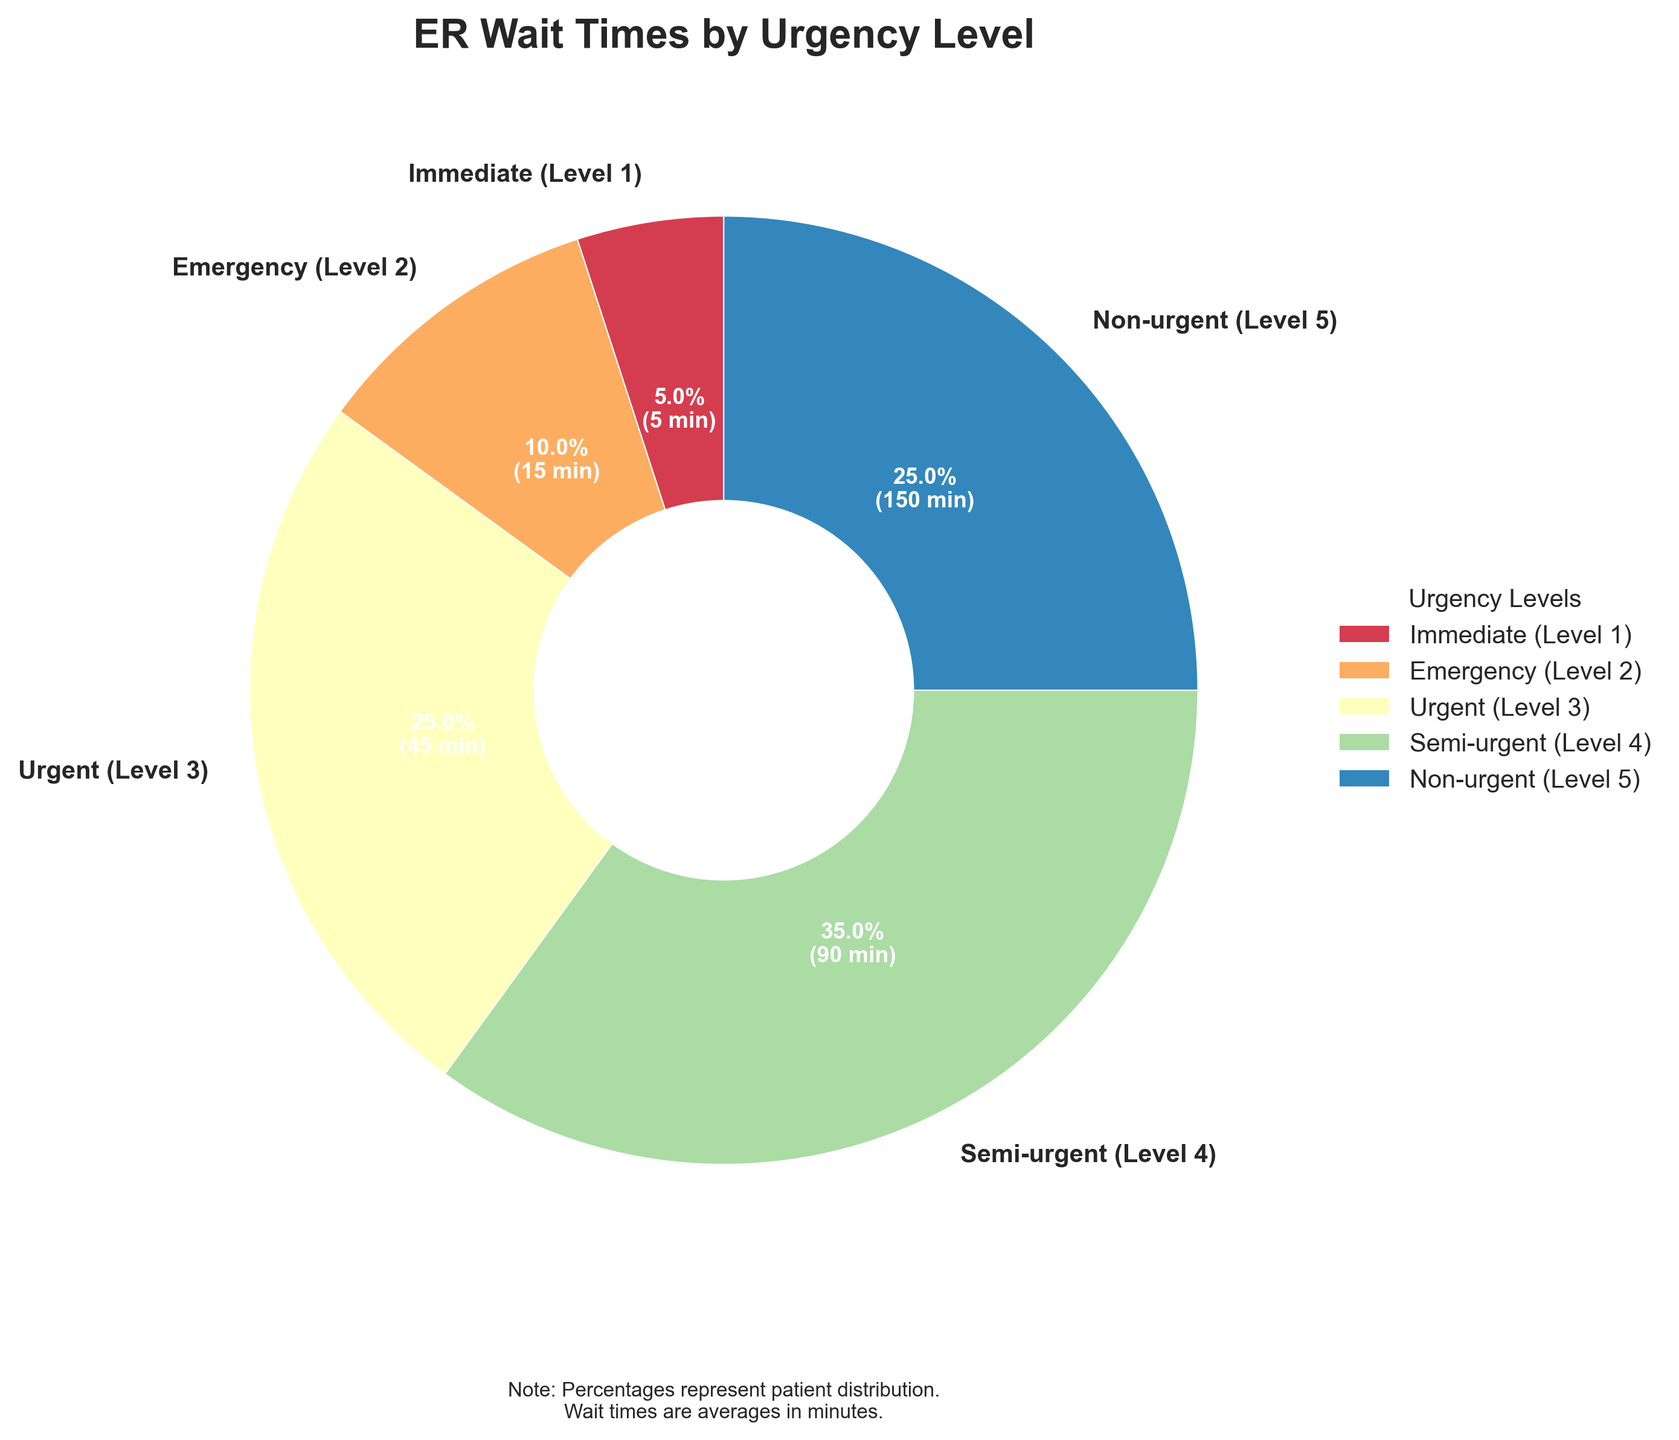What percentage of patients have urgent or higher urgency levels? Add the percentages for Immediate (Level 1), Emergency (Level 2), and Urgent (Level 3): 5% + 10% + 25% = 40%
Answer: 40% Which urgency level has the highest average wait time? The pie chart shows that Non-urgent (Level 5) has the highest average wait time of 150 minutes.
Answer: Non-urgent (Level 5) Which urgency level occupies the largest section of the pie chart? The section representing Semi-urgent (Level 4) is the largest, with 35% of patients.
Answer: Semi-urgent (Level 4) What is the combined average wait time for Semi-urgent and Non-urgent patients? Add the average wait times for Semi-urgent (90 minutes) and Non-urgent (150 minutes): 90 + 150 = 240 minutes.
Answer: 240 minutes How does the average wait time for Emergency (Level 2) patients compare to that for Immediate (Level 1) patients? The wait time for Emergency (15 minutes) is higher than for Immediate (5 minutes).
Answer: Higher What portion of the pie chart is dedicated to the two least urgent levels combined? Add the percentages for Semi-urgent (35%) and Non-urgent (25%): 35% + 25% = 60%
Answer: 60% What color represents the Urgent (Level 3) category in the pie chart? The color for Urgent (Level 3) can be identified by looking at the corresponding section in the pie chart. This will depend on the specific color palette used but will be clearly distinct.
Answer: [Color used for Urgent (Level 3)] Which level has the smallest percentage of patients, and what is that percentage? Immediate (Level 1) has the smallest percentage of patients with 5%.
Answer: 5% How does the wait time distribution for Urgent (Level 3) compare to that for Emergency (Level 2) in terms of percentages? Urgent (Level 3) makes up 25% of the patients, which is higher than Emergency (Level 2) at 10%.
Answer: Higher What insights can we draw about the relationship between urgency levels and average wait times? Urgency levels with lower wait times (Immediate, Emergency) have fewer patients compared to levels with higher wait times (Semi-urgent, Non-urgent). This suggests that more critical patients are seen faster, while less critical patients wait longer.
Answer: More critical patients are seen faster, less critical wait longer 